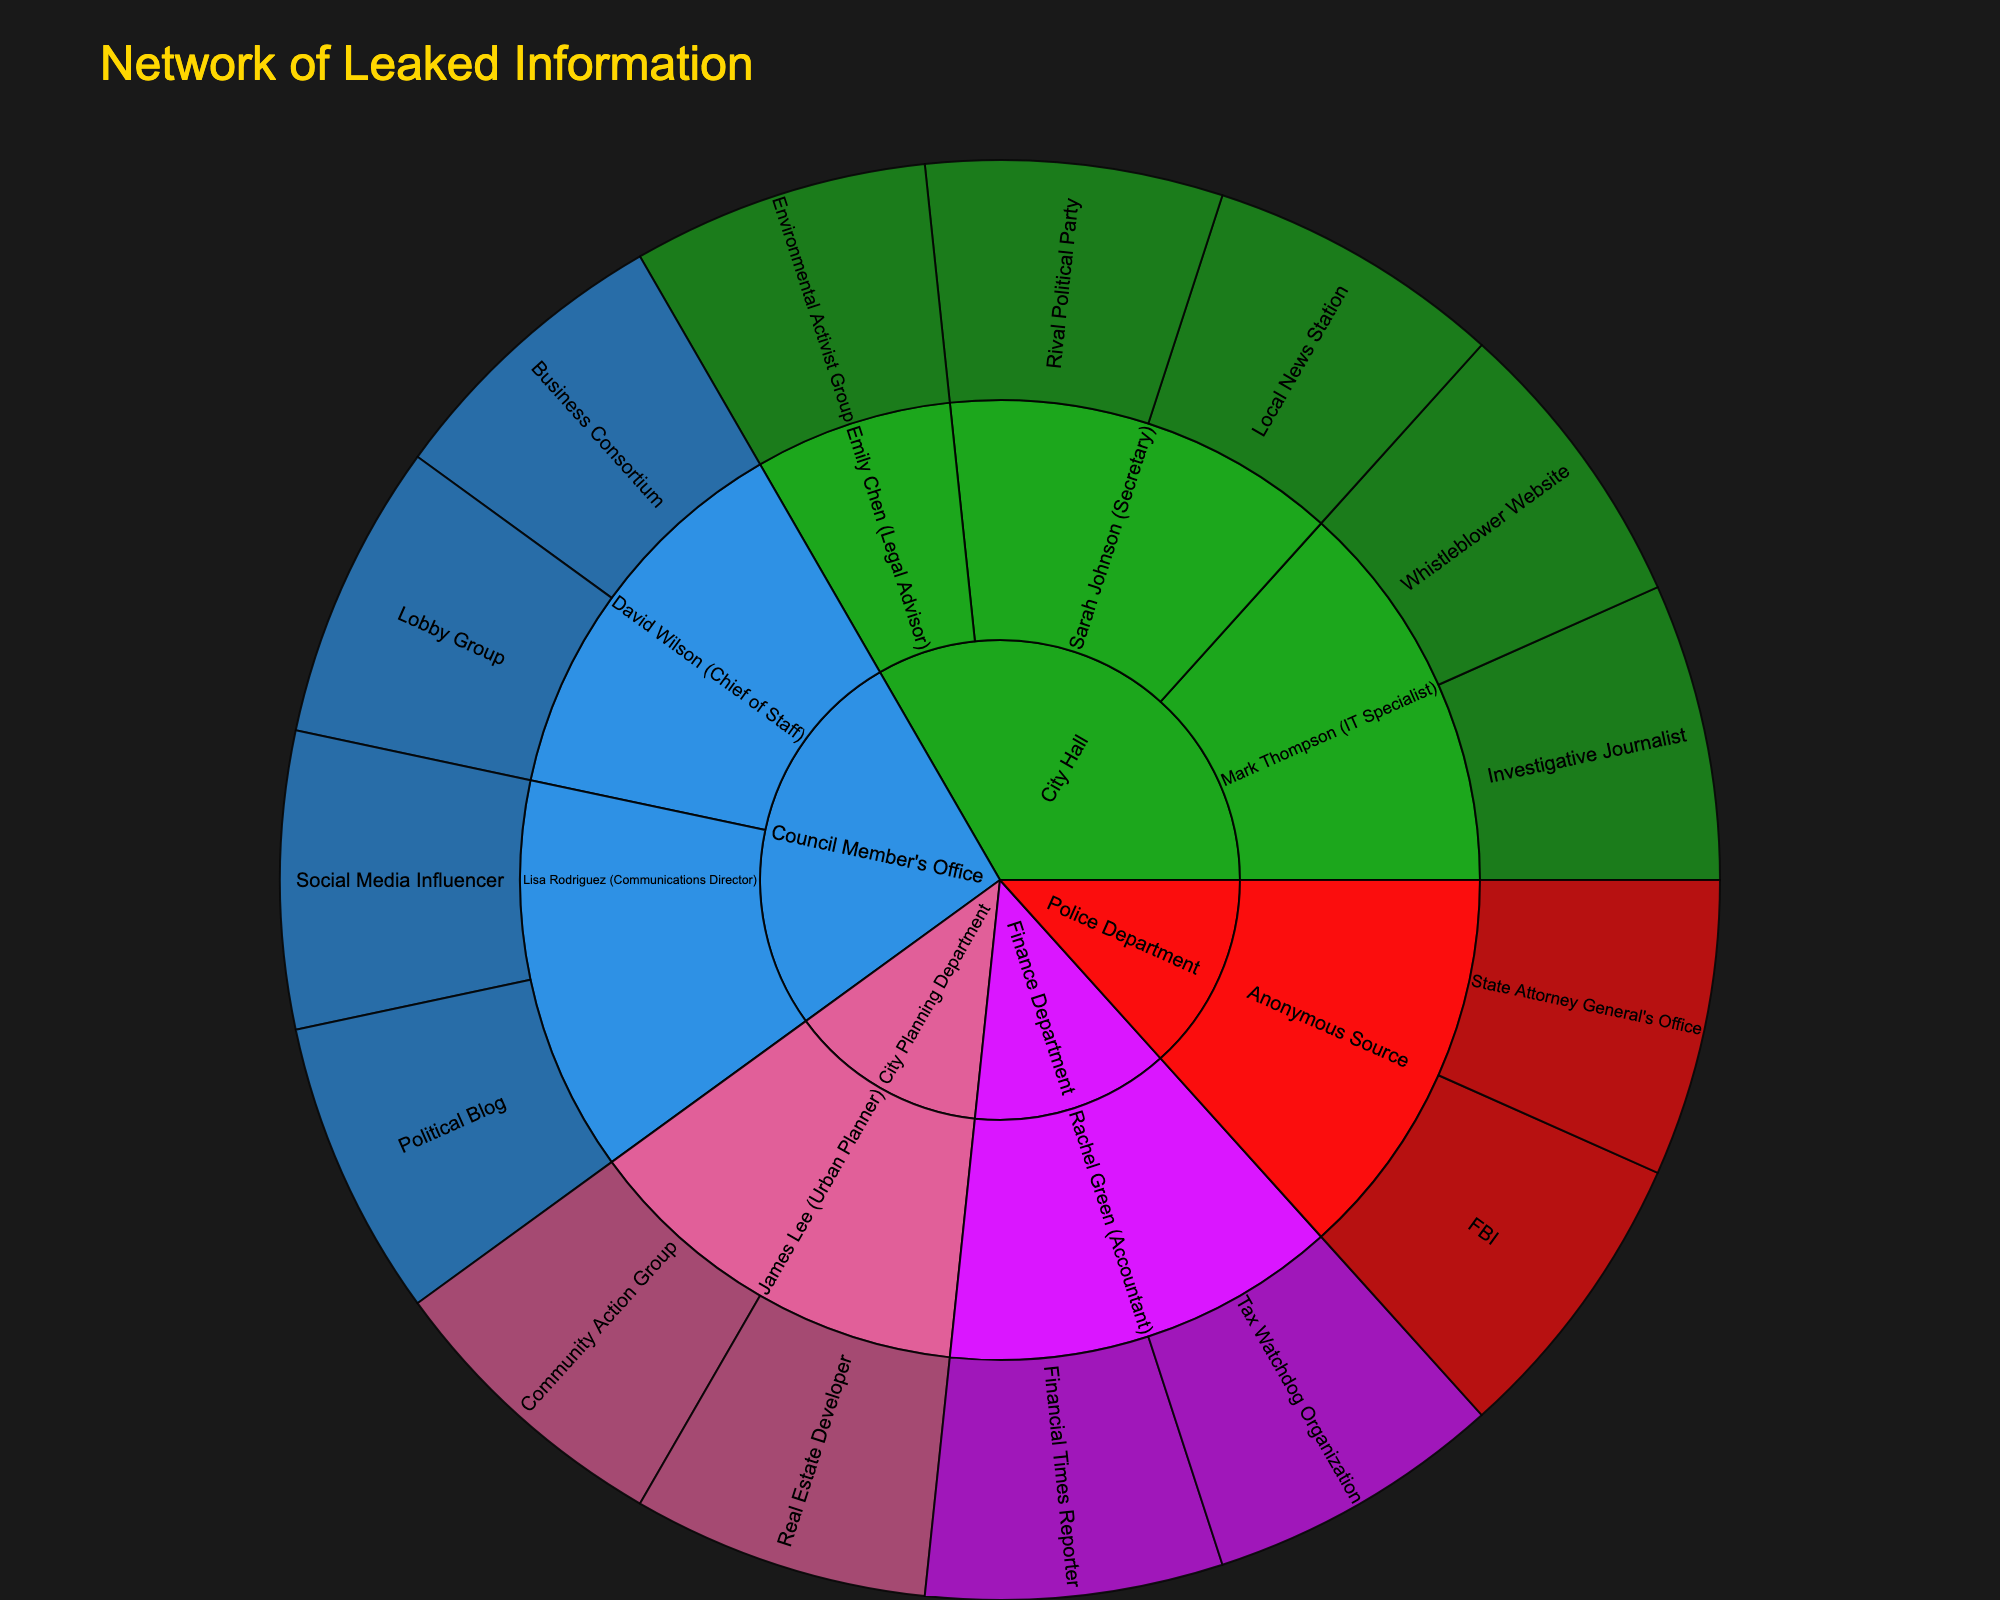What is the title of the figure? The title of the figure is usually prominently displayed at the top and signifies the main subject of the visualization.
Answer: Network of Leaked Information Which source has the most connections in the plot? Examine the size and spread of each segment originating from different 'Source' categories. The source with the most branches indicates the highest number of connections.
Answer: City Hall How many intermediaries are connected to the Council Member's Office? Count the number of unique intermediary segments branching out from 'Council Member's Office'.
Answer: 2 What is the recipient connected to the Police Department's Anonymous Source? Follow the path from 'Police Department' to 'Anonymous Source', and then to the recipient segment at the end of this path.
Answer: FBI, State Attorney General's Office Which intermediary has the most recipients? Identify which intermediary segment has the most branches leading to recipient segments.
Answer: Sarah Johnson (Secretary) Compare the number of connections from City Planning Department and Finance Department. Which one is greater? Count the total number of connections starting from each of these sources and compare them.
Answer: City Planning Department Identify all the intermediaries from City Hall and list their connected recipients. Identify segments branching off from 'City Hall' to intermediaries, then list out all outreach recipient segments from each intermediary.
Answer: Sarah Johnson (Local News Station, Rival Political Party), Mark Thompson (Investigative Journalist, Whistleblower Website), Emily Chen (Environmental Activist Group) Which department has a connection to a Social Media Influencer, and through which intermediary? Follow the path leading to 'Social Media Influencer', trace it back to identify the intermediary and the original source.
Answer: Council Member's Office, Lisa Rodriguez (Communications Director) What is the total number of recipients connected to all sources? Sum up all the leaf-level segments (recipients) in the plot.
Answer: 14 